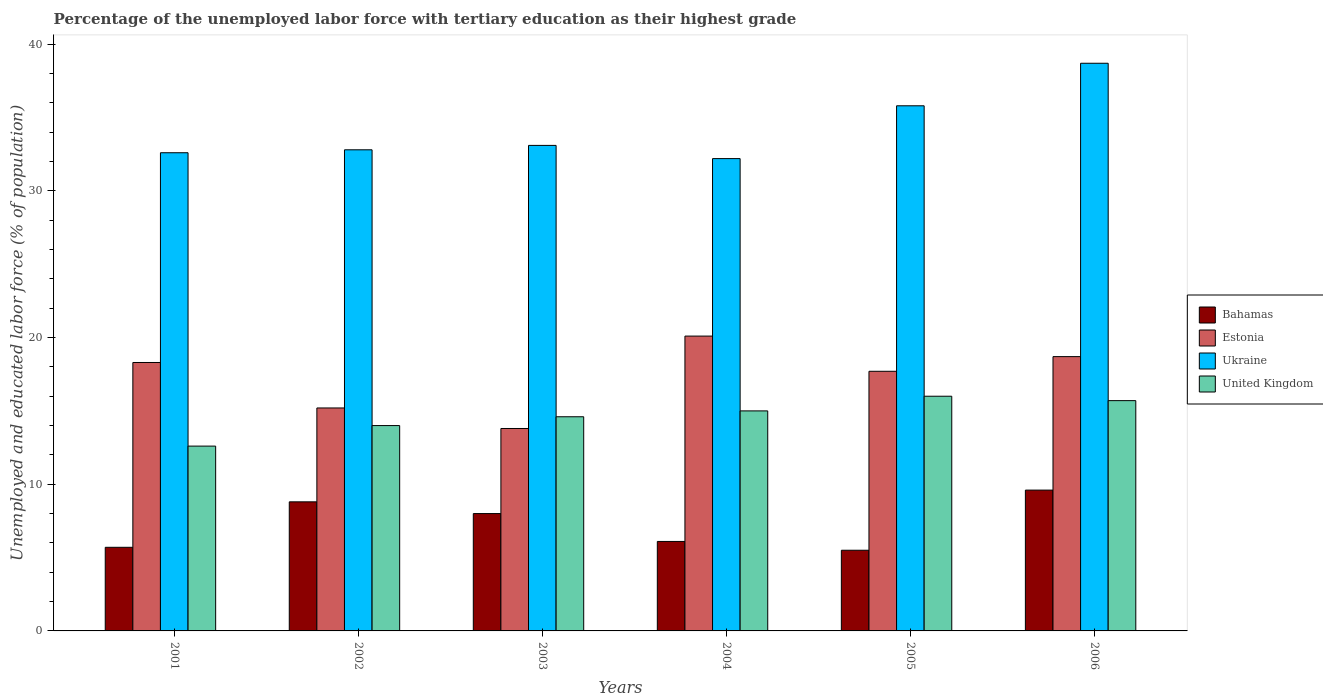How many different coloured bars are there?
Your answer should be very brief. 4. How many groups of bars are there?
Provide a short and direct response. 6. Are the number of bars on each tick of the X-axis equal?
Offer a very short reply. Yes. In how many cases, is the number of bars for a given year not equal to the number of legend labels?
Your answer should be very brief. 0. What is the percentage of the unemployed labor force with tertiary education in Estonia in 2006?
Offer a very short reply. 18.7. Across all years, what is the maximum percentage of the unemployed labor force with tertiary education in Ukraine?
Provide a short and direct response. 38.7. Across all years, what is the minimum percentage of the unemployed labor force with tertiary education in Bahamas?
Your answer should be compact. 5.5. In which year was the percentage of the unemployed labor force with tertiary education in Ukraine maximum?
Make the answer very short. 2006. In which year was the percentage of the unemployed labor force with tertiary education in Estonia minimum?
Offer a terse response. 2003. What is the total percentage of the unemployed labor force with tertiary education in Estonia in the graph?
Your answer should be very brief. 103.8. What is the difference between the percentage of the unemployed labor force with tertiary education in Estonia in 2001 and that in 2002?
Make the answer very short. 3.1. What is the difference between the percentage of the unemployed labor force with tertiary education in United Kingdom in 2005 and the percentage of the unemployed labor force with tertiary education in Ukraine in 2003?
Your answer should be very brief. -17.1. What is the average percentage of the unemployed labor force with tertiary education in Ukraine per year?
Offer a terse response. 34.2. In the year 2002, what is the difference between the percentage of the unemployed labor force with tertiary education in United Kingdom and percentage of the unemployed labor force with tertiary education in Ukraine?
Make the answer very short. -18.8. In how many years, is the percentage of the unemployed labor force with tertiary education in United Kingdom greater than 2 %?
Keep it short and to the point. 6. What is the ratio of the percentage of the unemployed labor force with tertiary education in Bahamas in 2002 to that in 2005?
Offer a very short reply. 1.6. Is the percentage of the unemployed labor force with tertiary education in Bahamas in 2005 less than that in 2006?
Provide a short and direct response. Yes. What is the difference between the highest and the second highest percentage of the unemployed labor force with tertiary education in Estonia?
Keep it short and to the point. 1.4. What is the difference between the highest and the lowest percentage of the unemployed labor force with tertiary education in Ukraine?
Your answer should be very brief. 6.5. Is the sum of the percentage of the unemployed labor force with tertiary education in Estonia in 2002 and 2006 greater than the maximum percentage of the unemployed labor force with tertiary education in Bahamas across all years?
Offer a very short reply. Yes. Is it the case that in every year, the sum of the percentage of the unemployed labor force with tertiary education in United Kingdom and percentage of the unemployed labor force with tertiary education in Bahamas is greater than the sum of percentage of the unemployed labor force with tertiary education in Estonia and percentage of the unemployed labor force with tertiary education in Ukraine?
Give a very brief answer. No. What does the 3rd bar from the left in 2001 represents?
Offer a very short reply. Ukraine. What does the 4th bar from the right in 2006 represents?
Offer a very short reply. Bahamas. Is it the case that in every year, the sum of the percentage of the unemployed labor force with tertiary education in Bahamas and percentage of the unemployed labor force with tertiary education in Ukraine is greater than the percentage of the unemployed labor force with tertiary education in Estonia?
Offer a very short reply. Yes. How many bars are there?
Give a very brief answer. 24. Are all the bars in the graph horizontal?
Provide a succinct answer. No. How many years are there in the graph?
Offer a terse response. 6. What is the difference between two consecutive major ticks on the Y-axis?
Offer a very short reply. 10. How are the legend labels stacked?
Offer a terse response. Vertical. What is the title of the graph?
Give a very brief answer. Percentage of the unemployed labor force with tertiary education as their highest grade. Does "Azerbaijan" appear as one of the legend labels in the graph?
Keep it short and to the point. No. What is the label or title of the Y-axis?
Your answer should be very brief. Unemployed and educated labor force (% of population). What is the Unemployed and educated labor force (% of population) in Bahamas in 2001?
Provide a short and direct response. 5.7. What is the Unemployed and educated labor force (% of population) of Estonia in 2001?
Provide a succinct answer. 18.3. What is the Unemployed and educated labor force (% of population) of Ukraine in 2001?
Provide a succinct answer. 32.6. What is the Unemployed and educated labor force (% of population) of United Kingdom in 2001?
Offer a very short reply. 12.6. What is the Unemployed and educated labor force (% of population) of Bahamas in 2002?
Give a very brief answer. 8.8. What is the Unemployed and educated labor force (% of population) of Estonia in 2002?
Offer a very short reply. 15.2. What is the Unemployed and educated labor force (% of population) of Ukraine in 2002?
Your answer should be compact. 32.8. What is the Unemployed and educated labor force (% of population) of United Kingdom in 2002?
Your answer should be compact. 14. What is the Unemployed and educated labor force (% of population) in Bahamas in 2003?
Provide a succinct answer. 8. What is the Unemployed and educated labor force (% of population) of Estonia in 2003?
Keep it short and to the point. 13.8. What is the Unemployed and educated labor force (% of population) in Ukraine in 2003?
Provide a succinct answer. 33.1. What is the Unemployed and educated labor force (% of population) in United Kingdom in 2003?
Provide a succinct answer. 14.6. What is the Unemployed and educated labor force (% of population) in Bahamas in 2004?
Your answer should be very brief. 6.1. What is the Unemployed and educated labor force (% of population) of Estonia in 2004?
Provide a succinct answer. 20.1. What is the Unemployed and educated labor force (% of population) in Ukraine in 2004?
Give a very brief answer. 32.2. What is the Unemployed and educated labor force (% of population) of United Kingdom in 2004?
Provide a succinct answer. 15. What is the Unemployed and educated labor force (% of population) in Estonia in 2005?
Offer a terse response. 17.7. What is the Unemployed and educated labor force (% of population) of Ukraine in 2005?
Give a very brief answer. 35.8. What is the Unemployed and educated labor force (% of population) in United Kingdom in 2005?
Keep it short and to the point. 16. What is the Unemployed and educated labor force (% of population) of Bahamas in 2006?
Provide a succinct answer. 9.6. What is the Unemployed and educated labor force (% of population) of Estonia in 2006?
Offer a very short reply. 18.7. What is the Unemployed and educated labor force (% of population) of Ukraine in 2006?
Ensure brevity in your answer.  38.7. What is the Unemployed and educated labor force (% of population) of United Kingdom in 2006?
Give a very brief answer. 15.7. Across all years, what is the maximum Unemployed and educated labor force (% of population) in Bahamas?
Make the answer very short. 9.6. Across all years, what is the maximum Unemployed and educated labor force (% of population) in Estonia?
Provide a succinct answer. 20.1. Across all years, what is the maximum Unemployed and educated labor force (% of population) in Ukraine?
Your response must be concise. 38.7. Across all years, what is the minimum Unemployed and educated labor force (% of population) in Estonia?
Your answer should be compact. 13.8. Across all years, what is the minimum Unemployed and educated labor force (% of population) of Ukraine?
Your response must be concise. 32.2. Across all years, what is the minimum Unemployed and educated labor force (% of population) of United Kingdom?
Keep it short and to the point. 12.6. What is the total Unemployed and educated labor force (% of population) of Bahamas in the graph?
Offer a terse response. 43.7. What is the total Unemployed and educated labor force (% of population) in Estonia in the graph?
Make the answer very short. 103.8. What is the total Unemployed and educated labor force (% of population) of Ukraine in the graph?
Give a very brief answer. 205.2. What is the total Unemployed and educated labor force (% of population) of United Kingdom in the graph?
Offer a very short reply. 87.9. What is the difference between the Unemployed and educated labor force (% of population) of Estonia in 2001 and that in 2002?
Provide a short and direct response. 3.1. What is the difference between the Unemployed and educated labor force (% of population) in Bahamas in 2001 and that in 2003?
Offer a terse response. -2.3. What is the difference between the Unemployed and educated labor force (% of population) of Estonia in 2001 and that in 2003?
Your response must be concise. 4.5. What is the difference between the Unemployed and educated labor force (% of population) in United Kingdom in 2001 and that in 2003?
Provide a short and direct response. -2. What is the difference between the Unemployed and educated labor force (% of population) of United Kingdom in 2001 and that in 2004?
Make the answer very short. -2.4. What is the difference between the Unemployed and educated labor force (% of population) in Ukraine in 2001 and that in 2005?
Give a very brief answer. -3.2. What is the difference between the Unemployed and educated labor force (% of population) of United Kingdom in 2001 and that in 2005?
Give a very brief answer. -3.4. What is the difference between the Unemployed and educated labor force (% of population) in United Kingdom in 2001 and that in 2006?
Your response must be concise. -3.1. What is the difference between the Unemployed and educated labor force (% of population) in Estonia in 2002 and that in 2003?
Make the answer very short. 1.4. What is the difference between the Unemployed and educated labor force (% of population) in Bahamas in 2002 and that in 2006?
Give a very brief answer. -0.8. What is the difference between the Unemployed and educated labor force (% of population) of Ukraine in 2002 and that in 2006?
Your response must be concise. -5.9. What is the difference between the Unemployed and educated labor force (% of population) in Bahamas in 2003 and that in 2004?
Your answer should be compact. 1.9. What is the difference between the Unemployed and educated labor force (% of population) of Estonia in 2003 and that in 2004?
Ensure brevity in your answer.  -6.3. What is the difference between the Unemployed and educated labor force (% of population) of Ukraine in 2003 and that in 2004?
Keep it short and to the point. 0.9. What is the difference between the Unemployed and educated labor force (% of population) of United Kingdom in 2003 and that in 2004?
Keep it short and to the point. -0.4. What is the difference between the Unemployed and educated labor force (% of population) of Bahamas in 2003 and that in 2005?
Make the answer very short. 2.5. What is the difference between the Unemployed and educated labor force (% of population) in Estonia in 2003 and that in 2005?
Offer a very short reply. -3.9. What is the difference between the Unemployed and educated labor force (% of population) of Ukraine in 2003 and that in 2005?
Keep it short and to the point. -2.7. What is the difference between the Unemployed and educated labor force (% of population) in United Kingdom in 2003 and that in 2005?
Your answer should be compact. -1.4. What is the difference between the Unemployed and educated labor force (% of population) in Bahamas in 2003 and that in 2006?
Offer a very short reply. -1.6. What is the difference between the Unemployed and educated labor force (% of population) in Ukraine in 2003 and that in 2006?
Provide a succinct answer. -5.6. What is the difference between the Unemployed and educated labor force (% of population) in Estonia in 2004 and that in 2005?
Give a very brief answer. 2.4. What is the difference between the Unemployed and educated labor force (% of population) of United Kingdom in 2004 and that in 2005?
Your answer should be compact. -1. What is the difference between the Unemployed and educated labor force (% of population) of Ukraine in 2004 and that in 2006?
Give a very brief answer. -6.5. What is the difference between the Unemployed and educated labor force (% of population) of United Kingdom in 2005 and that in 2006?
Keep it short and to the point. 0.3. What is the difference between the Unemployed and educated labor force (% of population) in Bahamas in 2001 and the Unemployed and educated labor force (% of population) in Ukraine in 2002?
Your answer should be very brief. -27.1. What is the difference between the Unemployed and educated labor force (% of population) of Bahamas in 2001 and the Unemployed and educated labor force (% of population) of United Kingdom in 2002?
Offer a very short reply. -8.3. What is the difference between the Unemployed and educated labor force (% of population) in Estonia in 2001 and the Unemployed and educated labor force (% of population) in United Kingdom in 2002?
Give a very brief answer. 4.3. What is the difference between the Unemployed and educated labor force (% of population) of Bahamas in 2001 and the Unemployed and educated labor force (% of population) of Ukraine in 2003?
Offer a very short reply. -27.4. What is the difference between the Unemployed and educated labor force (% of population) of Estonia in 2001 and the Unemployed and educated labor force (% of population) of Ukraine in 2003?
Your response must be concise. -14.8. What is the difference between the Unemployed and educated labor force (% of population) in Ukraine in 2001 and the Unemployed and educated labor force (% of population) in United Kingdom in 2003?
Your answer should be very brief. 18. What is the difference between the Unemployed and educated labor force (% of population) of Bahamas in 2001 and the Unemployed and educated labor force (% of population) of Estonia in 2004?
Your answer should be very brief. -14.4. What is the difference between the Unemployed and educated labor force (% of population) in Bahamas in 2001 and the Unemployed and educated labor force (% of population) in Ukraine in 2004?
Give a very brief answer. -26.5. What is the difference between the Unemployed and educated labor force (% of population) of Estonia in 2001 and the Unemployed and educated labor force (% of population) of Ukraine in 2004?
Keep it short and to the point. -13.9. What is the difference between the Unemployed and educated labor force (% of population) of Estonia in 2001 and the Unemployed and educated labor force (% of population) of United Kingdom in 2004?
Give a very brief answer. 3.3. What is the difference between the Unemployed and educated labor force (% of population) in Bahamas in 2001 and the Unemployed and educated labor force (% of population) in Ukraine in 2005?
Offer a terse response. -30.1. What is the difference between the Unemployed and educated labor force (% of population) in Bahamas in 2001 and the Unemployed and educated labor force (% of population) in United Kingdom in 2005?
Keep it short and to the point. -10.3. What is the difference between the Unemployed and educated labor force (% of population) of Estonia in 2001 and the Unemployed and educated labor force (% of population) of Ukraine in 2005?
Your answer should be very brief. -17.5. What is the difference between the Unemployed and educated labor force (% of population) in Bahamas in 2001 and the Unemployed and educated labor force (% of population) in Estonia in 2006?
Provide a succinct answer. -13. What is the difference between the Unemployed and educated labor force (% of population) of Bahamas in 2001 and the Unemployed and educated labor force (% of population) of Ukraine in 2006?
Give a very brief answer. -33. What is the difference between the Unemployed and educated labor force (% of population) of Bahamas in 2001 and the Unemployed and educated labor force (% of population) of United Kingdom in 2006?
Offer a terse response. -10. What is the difference between the Unemployed and educated labor force (% of population) in Estonia in 2001 and the Unemployed and educated labor force (% of population) in Ukraine in 2006?
Offer a very short reply. -20.4. What is the difference between the Unemployed and educated labor force (% of population) in Ukraine in 2001 and the Unemployed and educated labor force (% of population) in United Kingdom in 2006?
Offer a terse response. 16.9. What is the difference between the Unemployed and educated labor force (% of population) in Bahamas in 2002 and the Unemployed and educated labor force (% of population) in Estonia in 2003?
Your answer should be very brief. -5. What is the difference between the Unemployed and educated labor force (% of population) of Bahamas in 2002 and the Unemployed and educated labor force (% of population) of Ukraine in 2003?
Your answer should be very brief. -24.3. What is the difference between the Unemployed and educated labor force (% of population) in Estonia in 2002 and the Unemployed and educated labor force (% of population) in Ukraine in 2003?
Provide a short and direct response. -17.9. What is the difference between the Unemployed and educated labor force (% of population) of Ukraine in 2002 and the Unemployed and educated labor force (% of population) of United Kingdom in 2003?
Provide a succinct answer. 18.2. What is the difference between the Unemployed and educated labor force (% of population) in Bahamas in 2002 and the Unemployed and educated labor force (% of population) in Ukraine in 2004?
Offer a very short reply. -23.4. What is the difference between the Unemployed and educated labor force (% of population) in Ukraine in 2002 and the Unemployed and educated labor force (% of population) in United Kingdom in 2004?
Keep it short and to the point. 17.8. What is the difference between the Unemployed and educated labor force (% of population) of Bahamas in 2002 and the Unemployed and educated labor force (% of population) of Estonia in 2005?
Keep it short and to the point. -8.9. What is the difference between the Unemployed and educated labor force (% of population) of Estonia in 2002 and the Unemployed and educated labor force (% of population) of Ukraine in 2005?
Keep it short and to the point. -20.6. What is the difference between the Unemployed and educated labor force (% of population) in Ukraine in 2002 and the Unemployed and educated labor force (% of population) in United Kingdom in 2005?
Give a very brief answer. 16.8. What is the difference between the Unemployed and educated labor force (% of population) of Bahamas in 2002 and the Unemployed and educated labor force (% of population) of Estonia in 2006?
Ensure brevity in your answer.  -9.9. What is the difference between the Unemployed and educated labor force (% of population) of Bahamas in 2002 and the Unemployed and educated labor force (% of population) of Ukraine in 2006?
Provide a succinct answer. -29.9. What is the difference between the Unemployed and educated labor force (% of population) of Bahamas in 2002 and the Unemployed and educated labor force (% of population) of United Kingdom in 2006?
Make the answer very short. -6.9. What is the difference between the Unemployed and educated labor force (% of population) of Estonia in 2002 and the Unemployed and educated labor force (% of population) of Ukraine in 2006?
Keep it short and to the point. -23.5. What is the difference between the Unemployed and educated labor force (% of population) in Estonia in 2002 and the Unemployed and educated labor force (% of population) in United Kingdom in 2006?
Your answer should be very brief. -0.5. What is the difference between the Unemployed and educated labor force (% of population) in Ukraine in 2002 and the Unemployed and educated labor force (% of population) in United Kingdom in 2006?
Offer a very short reply. 17.1. What is the difference between the Unemployed and educated labor force (% of population) of Bahamas in 2003 and the Unemployed and educated labor force (% of population) of Estonia in 2004?
Offer a very short reply. -12.1. What is the difference between the Unemployed and educated labor force (% of population) of Bahamas in 2003 and the Unemployed and educated labor force (% of population) of Ukraine in 2004?
Keep it short and to the point. -24.2. What is the difference between the Unemployed and educated labor force (% of population) in Estonia in 2003 and the Unemployed and educated labor force (% of population) in Ukraine in 2004?
Provide a succinct answer. -18.4. What is the difference between the Unemployed and educated labor force (% of population) in Estonia in 2003 and the Unemployed and educated labor force (% of population) in United Kingdom in 2004?
Keep it short and to the point. -1.2. What is the difference between the Unemployed and educated labor force (% of population) in Ukraine in 2003 and the Unemployed and educated labor force (% of population) in United Kingdom in 2004?
Your answer should be very brief. 18.1. What is the difference between the Unemployed and educated labor force (% of population) of Bahamas in 2003 and the Unemployed and educated labor force (% of population) of Estonia in 2005?
Provide a short and direct response. -9.7. What is the difference between the Unemployed and educated labor force (% of population) of Bahamas in 2003 and the Unemployed and educated labor force (% of population) of Ukraine in 2005?
Keep it short and to the point. -27.8. What is the difference between the Unemployed and educated labor force (% of population) of Bahamas in 2003 and the Unemployed and educated labor force (% of population) of United Kingdom in 2005?
Your answer should be compact. -8. What is the difference between the Unemployed and educated labor force (% of population) of Bahamas in 2003 and the Unemployed and educated labor force (% of population) of Estonia in 2006?
Provide a succinct answer. -10.7. What is the difference between the Unemployed and educated labor force (% of population) of Bahamas in 2003 and the Unemployed and educated labor force (% of population) of Ukraine in 2006?
Offer a very short reply. -30.7. What is the difference between the Unemployed and educated labor force (% of population) in Estonia in 2003 and the Unemployed and educated labor force (% of population) in Ukraine in 2006?
Keep it short and to the point. -24.9. What is the difference between the Unemployed and educated labor force (% of population) of Estonia in 2003 and the Unemployed and educated labor force (% of population) of United Kingdom in 2006?
Ensure brevity in your answer.  -1.9. What is the difference between the Unemployed and educated labor force (% of population) of Ukraine in 2003 and the Unemployed and educated labor force (% of population) of United Kingdom in 2006?
Ensure brevity in your answer.  17.4. What is the difference between the Unemployed and educated labor force (% of population) in Bahamas in 2004 and the Unemployed and educated labor force (% of population) in Ukraine in 2005?
Offer a terse response. -29.7. What is the difference between the Unemployed and educated labor force (% of population) in Estonia in 2004 and the Unemployed and educated labor force (% of population) in Ukraine in 2005?
Your answer should be very brief. -15.7. What is the difference between the Unemployed and educated labor force (% of population) in Bahamas in 2004 and the Unemployed and educated labor force (% of population) in Estonia in 2006?
Your answer should be very brief. -12.6. What is the difference between the Unemployed and educated labor force (% of population) in Bahamas in 2004 and the Unemployed and educated labor force (% of population) in Ukraine in 2006?
Your response must be concise. -32.6. What is the difference between the Unemployed and educated labor force (% of population) of Estonia in 2004 and the Unemployed and educated labor force (% of population) of Ukraine in 2006?
Provide a short and direct response. -18.6. What is the difference between the Unemployed and educated labor force (% of population) in Estonia in 2004 and the Unemployed and educated labor force (% of population) in United Kingdom in 2006?
Offer a very short reply. 4.4. What is the difference between the Unemployed and educated labor force (% of population) of Bahamas in 2005 and the Unemployed and educated labor force (% of population) of Estonia in 2006?
Ensure brevity in your answer.  -13.2. What is the difference between the Unemployed and educated labor force (% of population) in Bahamas in 2005 and the Unemployed and educated labor force (% of population) in Ukraine in 2006?
Give a very brief answer. -33.2. What is the difference between the Unemployed and educated labor force (% of population) of Bahamas in 2005 and the Unemployed and educated labor force (% of population) of United Kingdom in 2006?
Offer a terse response. -10.2. What is the difference between the Unemployed and educated labor force (% of population) in Ukraine in 2005 and the Unemployed and educated labor force (% of population) in United Kingdom in 2006?
Your answer should be compact. 20.1. What is the average Unemployed and educated labor force (% of population) in Bahamas per year?
Your answer should be very brief. 7.28. What is the average Unemployed and educated labor force (% of population) in Ukraine per year?
Provide a short and direct response. 34.2. What is the average Unemployed and educated labor force (% of population) of United Kingdom per year?
Make the answer very short. 14.65. In the year 2001, what is the difference between the Unemployed and educated labor force (% of population) of Bahamas and Unemployed and educated labor force (% of population) of Estonia?
Provide a short and direct response. -12.6. In the year 2001, what is the difference between the Unemployed and educated labor force (% of population) in Bahamas and Unemployed and educated labor force (% of population) in Ukraine?
Provide a short and direct response. -26.9. In the year 2001, what is the difference between the Unemployed and educated labor force (% of population) in Bahamas and Unemployed and educated labor force (% of population) in United Kingdom?
Your answer should be very brief. -6.9. In the year 2001, what is the difference between the Unemployed and educated labor force (% of population) of Estonia and Unemployed and educated labor force (% of population) of Ukraine?
Offer a very short reply. -14.3. In the year 2001, what is the difference between the Unemployed and educated labor force (% of population) of Ukraine and Unemployed and educated labor force (% of population) of United Kingdom?
Your answer should be compact. 20. In the year 2002, what is the difference between the Unemployed and educated labor force (% of population) of Bahamas and Unemployed and educated labor force (% of population) of Estonia?
Your response must be concise. -6.4. In the year 2002, what is the difference between the Unemployed and educated labor force (% of population) in Bahamas and Unemployed and educated labor force (% of population) in Ukraine?
Provide a succinct answer. -24. In the year 2002, what is the difference between the Unemployed and educated labor force (% of population) of Estonia and Unemployed and educated labor force (% of population) of Ukraine?
Provide a succinct answer. -17.6. In the year 2002, what is the difference between the Unemployed and educated labor force (% of population) in Estonia and Unemployed and educated labor force (% of population) in United Kingdom?
Your answer should be compact. 1.2. In the year 2003, what is the difference between the Unemployed and educated labor force (% of population) of Bahamas and Unemployed and educated labor force (% of population) of Estonia?
Give a very brief answer. -5.8. In the year 2003, what is the difference between the Unemployed and educated labor force (% of population) of Bahamas and Unemployed and educated labor force (% of population) of Ukraine?
Ensure brevity in your answer.  -25.1. In the year 2003, what is the difference between the Unemployed and educated labor force (% of population) of Bahamas and Unemployed and educated labor force (% of population) of United Kingdom?
Your response must be concise. -6.6. In the year 2003, what is the difference between the Unemployed and educated labor force (% of population) of Estonia and Unemployed and educated labor force (% of population) of Ukraine?
Provide a succinct answer. -19.3. In the year 2003, what is the difference between the Unemployed and educated labor force (% of population) of Estonia and Unemployed and educated labor force (% of population) of United Kingdom?
Provide a short and direct response. -0.8. In the year 2003, what is the difference between the Unemployed and educated labor force (% of population) in Ukraine and Unemployed and educated labor force (% of population) in United Kingdom?
Provide a succinct answer. 18.5. In the year 2004, what is the difference between the Unemployed and educated labor force (% of population) of Bahamas and Unemployed and educated labor force (% of population) of Ukraine?
Your answer should be very brief. -26.1. In the year 2004, what is the difference between the Unemployed and educated labor force (% of population) of Estonia and Unemployed and educated labor force (% of population) of United Kingdom?
Your answer should be compact. 5.1. In the year 2005, what is the difference between the Unemployed and educated labor force (% of population) in Bahamas and Unemployed and educated labor force (% of population) in Ukraine?
Your answer should be compact. -30.3. In the year 2005, what is the difference between the Unemployed and educated labor force (% of population) in Bahamas and Unemployed and educated labor force (% of population) in United Kingdom?
Your response must be concise. -10.5. In the year 2005, what is the difference between the Unemployed and educated labor force (% of population) of Estonia and Unemployed and educated labor force (% of population) of Ukraine?
Provide a succinct answer. -18.1. In the year 2005, what is the difference between the Unemployed and educated labor force (% of population) in Estonia and Unemployed and educated labor force (% of population) in United Kingdom?
Ensure brevity in your answer.  1.7. In the year 2005, what is the difference between the Unemployed and educated labor force (% of population) in Ukraine and Unemployed and educated labor force (% of population) in United Kingdom?
Keep it short and to the point. 19.8. In the year 2006, what is the difference between the Unemployed and educated labor force (% of population) of Bahamas and Unemployed and educated labor force (% of population) of Estonia?
Offer a terse response. -9.1. In the year 2006, what is the difference between the Unemployed and educated labor force (% of population) in Bahamas and Unemployed and educated labor force (% of population) in Ukraine?
Provide a succinct answer. -29.1. In the year 2006, what is the difference between the Unemployed and educated labor force (% of population) in Estonia and Unemployed and educated labor force (% of population) in United Kingdom?
Your answer should be very brief. 3. What is the ratio of the Unemployed and educated labor force (% of population) in Bahamas in 2001 to that in 2002?
Ensure brevity in your answer.  0.65. What is the ratio of the Unemployed and educated labor force (% of population) of Estonia in 2001 to that in 2002?
Keep it short and to the point. 1.2. What is the ratio of the Unemployed and educated labor force (% of population) in Ukraine in 2001 to that in 2002?
Your response must be concise. 0.99. What is the ratio of the Unemployed and educated labor force (% of population) of United Kingdom in 2001 to that in 2002?
Your answer should be very brief. 0.9. What is the ratio of the Unemployed and educated labor force (% of population) in Bahamas in 2001 to that in 2003?
Your answer should be compact. 0.71. What is the ratio of the Unemployed and educated labor force (% of population) in Estonia in 2001 to that in 2003?
Make the answer very short. 1.33. What is the ratio of the Unemployed and educated labor force (% of population) of Ukraine in 2001 to that in 2003?
Ensure brevity in your answer.  0.98. What is the ratio of the Unemployed and educated labor force (% of population) of United Kingdom in 2001 to that in 2003?
Your answer should be compact. 0.86. What is the ratio of the Unemployed and educated labor force (% of population) of Bahamas in 2001 to that in 2004?
Provide a succinct answer. 0.93. What is the ratio of the Unemployed and educated labor force (% of population) in Estonia in 2001 to that in 2004?
Make the answer very short. 0.91. What is the ratio of the Unemployed and educated labor force (% of population) of Ukraine in 2001 to that in 2004?
Give a very brief answer. 1.01. What is the ratio of the Unemployed and educated labor force (% of population) in United Kingdom in 2001 to that in 2004?
Offer a terse response. 0.84. What is the ratio of the Unemployed and educated labor force (% of population) in Bahamas in 2001 to that in 2005?
Your answer should be compact. 1.04. What is the ratio of the Unemployed and educated labor force (% of population) of Estonia in 2001 to that in 2005?
Your answer should be very brief. 1.03. What is the ratio of the Unemployed and educated labor force (% of population) of Ukraine in 2001 to that in 2005?
Keep it short and to the point. 0.91. What is the ratio of the Unemployed and educated labor force (% of population) of United Kingdom in 2001 to that in 2005?
Provide a succinct answer. 0.79. What is the ratio of the Unemployed and educated labor force (% of population) of Bahamas in 2001 to that in 2006?
Provide a succinct answer. 0.59. What is the ratio of the Unemployed and educated labor force (% of population) in Estonia in 2001 to that in 2006?
Your response must be concise. 0.98. What is the ratio of the Unemployed and educated labor force (% of population) in Ukraine in 2001 to that in 2006?
Keep it short and to the point. 0.84. What is the ratio of the Unemployed and educated labor force (% of population) in United Kingdom in 2001 to that in 2006?
Your answer should be very brief. 0.8. What is the ratio of the Unemployed and educated labor force (% of population) of Estonia in 2002 to that in 2003?
Provide a short and direct response. 1.1. What is the ratio of the Unemployed and educated labor force (% of population) in Ukraine in 2002 to that in 2003?
Offer a very short reply. 0.99. What is the ratio of the Unemployed and educated labor force (% of population) in United Kingdom in 2002 to that in 2003?
Your response must be concise. 0.96. What is the ratio of the Unemployed and educated labor force (% of population) in Bahamas in 2002 to that in 2004?
Offer a terse response. 1.44. What is the ratio of the Unemployed and educated labor force (% of population) in Estonia in 2002 to that in 2004?
Keep it short and to the point. 0.76. What is the ratio of the Unemployed and educated labor force (% of population) in Ukraine in 2002 to that in 2004?
Offer a very short reply. 1.02. What is the ratio of the Unemployed and educated labor force (% of population) in United Kingdom in 2002 to that in 2004?
Make the answer very short. 0.93. What is the ratio of the Unemployed and educated labor force (% of population) of Estonia in 2002 to that in 2005?
Ensure brevity in your answer.  0.86. What is the ratio of the Unemployed and educated labor force (% of population) in Ukraine in 2002 to that in 2005?
Provide a short and direct response. 0.92. What is the ratio of the Unemployed and educated labor force (% of population) in United Kingdom in 2002 to that in 2005?
Give a very brief answer. 0.88. What is the ratio of the Unemployed and educated labor force (% of population) of Bahamas in 2002 to that in 2006?
Your response must be concise. 0.92. What is the ratio of the Unemployed and educated labor force (% of population) of Estonia in 2002 to that in 2006?
Provide a succinct answer. 0.81. What is the ratio of the Unemployed and educated labor force (% of population) of Ukraine in 2002 to that in 2006?
Your response must be concise. 0.85. What is the ratio of the Unemployed and educated labor force (% of population) in United Kingdom in 2002 to that in 2006?
Keep it short and to the point. 0.89. What is the ratio of the Unemployed and educated labor force (% of population) of Bahamas in 2003 to that in 2004?
Offer a terse response. 1.31. What is the ratio of the Unemployed and educated labor force (% of population) in Estonia in 2003 to that in 2004?
Offer a terse response. 0.69. What is the ratio of the Unemployed and educated labor force (% of population) in Ukraine in 2003 to that in 2004?
Your response must be concise. 1.03. What is the ratio of the Unemployed and educated labor force (% of population) in United Kingdom in 2003 to that in 2004?
Provide a short and direct response. 0.97. What is the ratio of the Unemployed and educated labor force (% of population) of Bahamas in 2003 to that in 2005?
Give a very brief answer. 1.45. What is the ratio of the Unemployed and educated labor force (% of population) of Estonia in 2003 to that in 2005?
Keep it short and to the point. 0.78. What is the ratio of the Unemployed and educated labor force (% of population) of Ukraine in 2003 to that in 2005?
Offer a terse response. 0.92. What is the ratio of the Unemployed and educated labor force (% of population) in United Kingdom in 2003 to that in 2005?
Offer a very short reply. 0.91. What is the ratio of the Unemployed and educated labor force (% of population) of Bahamas in 2003 to that in 2006?
Your response must be concise. 0.83. What is the ratio of the Unemployed and educated labor force (% of population) in Estonia in 2003 to that in 2006?
Your answer should be very brief. 0.74. What is the ratio of the Unemployed and educated labor force (% of population) in Ukraine in 2003 to that in 2006?
Make the answer very short. 0.86. What is the ratio of the Unemployed and educated labor force (% of population) of United Kingdom in 2003 to that in 2006?
Provide a short and direct response. 0.93. What is the ratio of the Unemployed and educated labor force (% of population) of Bahamas in 2004 to that in 2005?
Provide a short and direct response. 1.11. What is the ratio of the Unemployed and educated labor force (% of population) in Estonia in 2004 to that in 2005?
Ensure brevity in your answer.  1.14. What is the ratio of the Unemployed and educated labor force (% of population) in Ukraine in 2004 to that in 2005?
Make the answer very short. 0.9. What is the ratio of the Unemployed and educated labor force (% of population) in Bahamas in 2004 to that in 2006?
Offer a terse response. 0.64. What is the ratio of the Unemployed and educated labor force (% of population) in Estonia in 2004 to that in 2006?
Ensure brevity in your answer.  1.07. What is the ratio of the Unemployed and educated labor force (% of population) of Ukraine in 2004 to that in 2006?
Offer a terse response. 0.83. What is the ratio of the Unemployed and educated labor force (% of population) of United Kingdom in 2004 to that in 2006?
Your answer should be compact. 0.96. What is the ratio of the Unemployed and educated labor force (% of population) of Bahamas in 2005 to that in 2006?
Provide a succinct answer. 0.57. What is the ratio of the Unemployed and educated labor force (% of population) of Estonia in 2005 to that in 2006?
Your answer should be compact. 0.95. What is the ratio of the Unemployed and educated labor force (% of population) in Ukraine in 2005 to that in 2006?
Your answer should be compact. 0.93. What is the ratio of the Unemployed and educated labor force (% of population) of United Kingdom in 2005 to that in 2006?
Provide a succinct answer. 1.02. What is the difference between the highest and the second highest Unemployed and educated labor force (% of population) of Estonia?
Provide a short and direct response. 1.4. What is the difference between the highest and the second highest Unemployed and educated labor force (% of population) of Ukraine?
Provide a short and direct response. 2.9. 